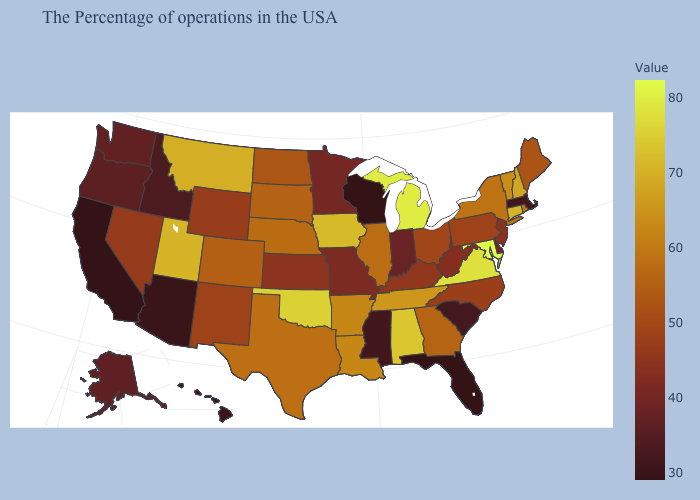Among the states that border Nebraska , which have the lowest value?
Quick response, please. Missouri. Among the states that border Arkansas , which have the lowest value?
Quick response, please. Mississippi. Does California have the lowest value in the West?
Answer briefly. Yes. Which states have the highest value in the USA?
Concise answer only. Maryland. Which states have the highest value in the USA?
Short answer required. Maryland. 